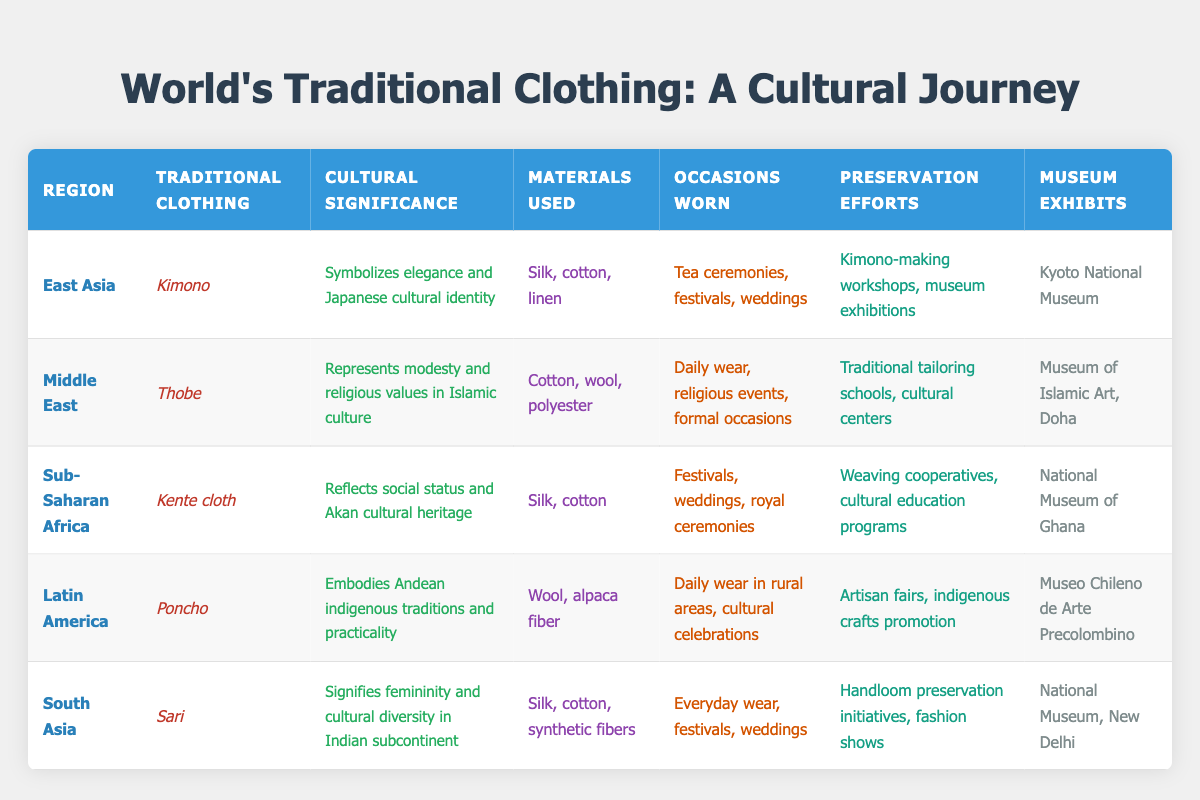What is the traditional clothing for South Asia? According to the table, the traditional clothing for South Asia is the Sari.
Answer: Sari Which region's traditional clothing is associated with festivals and weddings? The table mentions that both Kente cloth (Sub-Saharan Africa) and Sari (South Asia) are worn during festivals and weddings, along with Kimono (East Asia).
Answer: Kente cloth, Sari, Kimono Is Kente cloth made from wool? The table shows that Kente cloth is made from silk and cotton, not wool.
Answer: No Which region's clothing embodies Andean indigenous traditions? The Poncho, which is associated with Latin America, embodies Andean indigenous traditions according to the cultural significance provided.
Answer: Latin America What materials are used to make the Kimono? The table lists the materials used to make the Kimono as silk, cotton, and linen.
Answer: Silk, cotton, linen Which traditional clothing represents modesty in Islamic culture? The Thobe is recognized in the table as the traditional clothing representing modesty and religious values in Islamic culture.
Answer: Thobe Which region has preservation efforts involving artisan fairs? According to the table, preservation efforts that involve artisan fairs are associated with the Poncho in Latin America.
Answer: Latin America What is the average number of materials used in traditional clothing across all regions? The materials mentioned are: 3 for Kimono, 3 for Thobe, 2 for Kente cloth, 2 for Poncho, and 3 for Sari. Summing these gives 13. Dividing by 5 regions, the average is 13/5 = 2.6.
Answer: 2.6 Which museum exhibits the Sari? The table specifies that the National Museum in New Delhi exhibits the Sari.
Answer: National Museum, New Delhi 